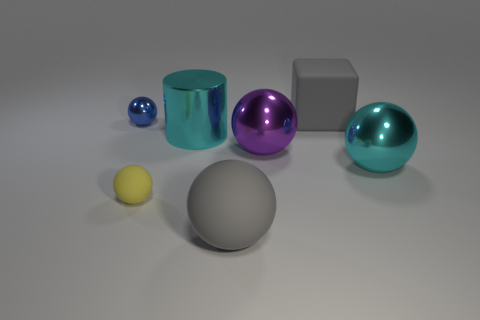What is the material of the large sphere that is the same color as the large matte cube?
Offer a very short reply. Rubber. What number of things are matte cubes or cyan objects left of the big cube?
Offer a very short reply. 2. What number of cyan spheres have the same size as the cylinder?
Your answer should be compact. 1. Are there fewer tiny objects to the right of the large cyan cylinder than cyan metallic cylinders that are behind the large matte ball?
Provide a short and direct response. Yes. How many metallic things are either large cyan balls or tiny blue things?
Give a very brief answer. 2. The tiny metal thing is what shape?
Your answer should be compact. Sphere. There is a gray sphere that is the same size as the gray block; what material is it?
Your response must be concise. Rubber. How many small things are purple objects or rubber blocks?
Provide a short and direct response. 0. Are any big rubber cubes visible?
Keep it short and to the point. Yes. What is the size of the purple ball that is the same material as the big cyan cylinder?
Provide a short and direct response. Large. 